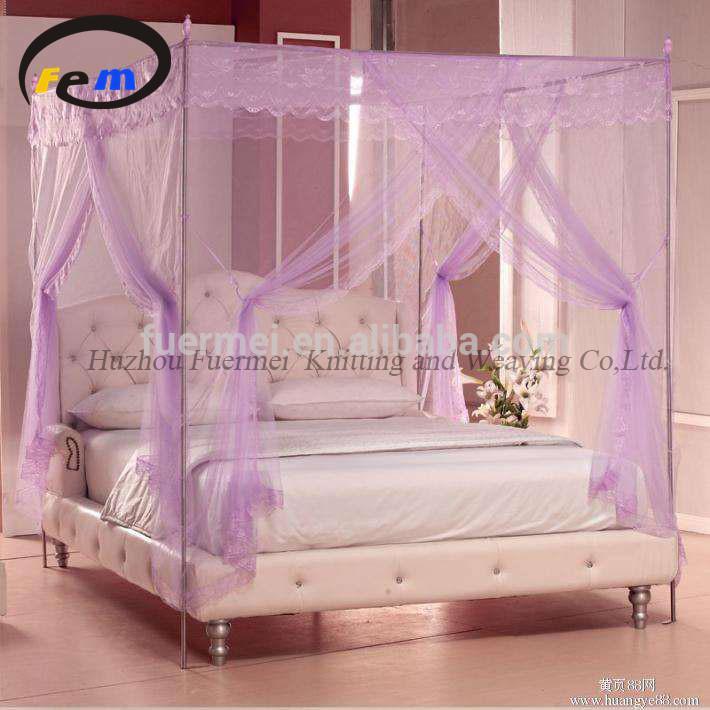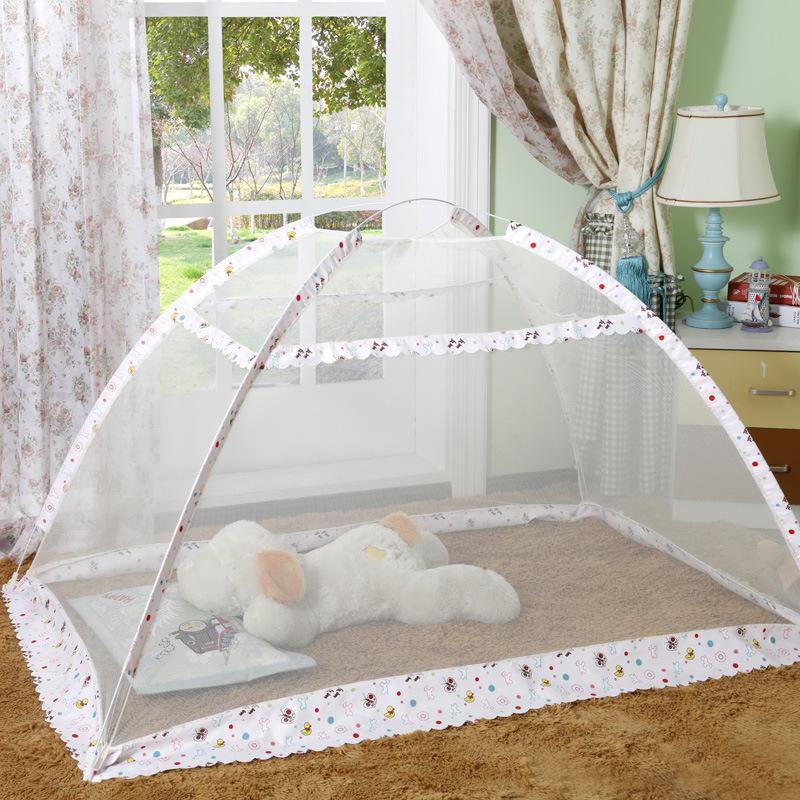The first image is the image on the left, the second image is the image on the right. Analyze the images presented: Is the assertion "An image shows a four-posted bed decorated with a curtain-tied lavender canopy." valid? Answer yes or no. Yes. The first image is the image on the left, the second image is the image on the right. Examine the images to the left and right. Is the description "The bedposts in one image have a draping that is lavender." accurate? Answer yes or no. Yes. 